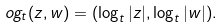<formula> <loc_0><loc_0><loc_500><loc_500>\L o g _ { t } ( z , w ) = ( \log _ { t } | z | , \log _ { t } | w | ) .</formula> 